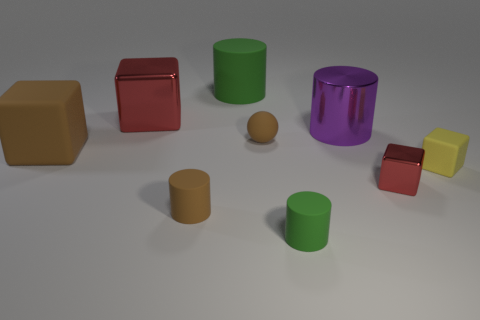How many things are either large metal objects or large rubber cylinders that are left of the yellow matte block?
Your answer should be compact. 3. There is a tiny brown matte cylinder that is on the left side of the green rubber thing that is in front of the big purple cylinder; how many small brown balls are on the left side of it?
Your response must be concise. 0. There is a small sphere that is the same material as the big green object; what color is it?
Offer a very short reply. Brown. Does the red metallic thing that is in front of the yellow matte thing have the same size as the brown cylinder?
Offer a very short reply. Yes. How many objects are large red cubes or green metallic objects?
Provide a short and direct response. 1. The small cylinder on the left side of the green rubber cylinder that is in front of the red shiny object that is behind the yellow matte object is made of what material?
Keep it short and to the point. Rubber. There is a green cylinder that is to the left of the small green matte object; what material is it?
Provide a succinct answer. Rubber. Are there any green rubber cylinders that have the same size as the yellow rubber object?
Your answer should be very brief. Yes. There is a metallic cube that is on the right side of the large red metal thing; is its color the same as the big metal cube?
Keep it short and to the point. Yes. How many purple objects are tiny shiny blocks or big metallic cylinders?
Keep it short and to the point. 1. 